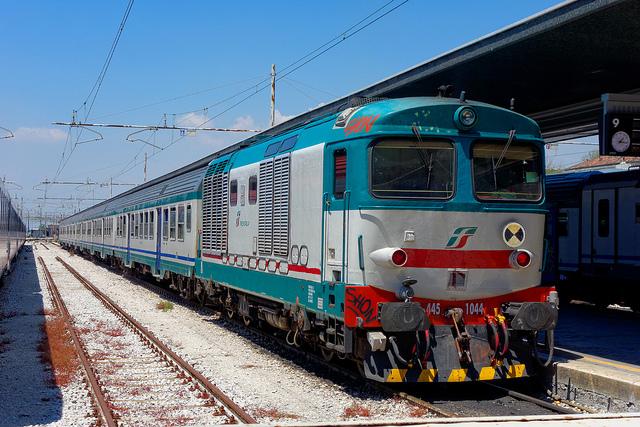How many windows on the train?
Quick response, please. 50. Was this picture taken at night?
Keep it brief. No. Is it raining?
Give a very brief answer. No. Is there any vegetation?
Give a very brief answer. No. What are the numbers on the front of the train?
Quick response, please. 445 1044. Why would someone wash the train?
Give a very brief answer. It's dirty. Does the sky mostly match the train?
Quick response, please. Yes. 